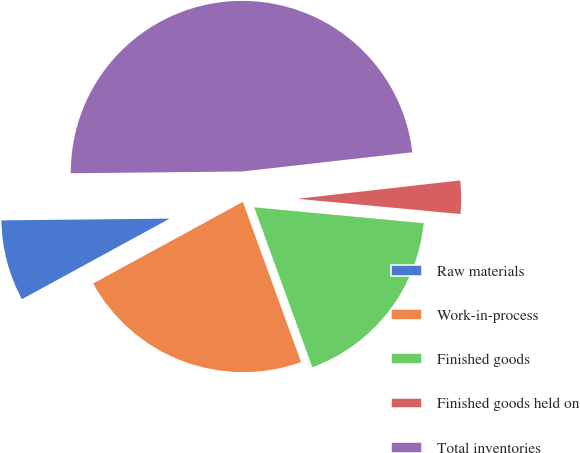<chart> <loc_0><loc_0><loc_500><loc_500><pie_chart><fcel>Raw materials<fcel>Work-in-process<fcel>Finished goods<fcel>Finished goods held on<fcel>Total inventories<nl><fcel>7.78%<fcel>22.6%<fcel>17.97%<fcel>3.27%<fcel>48.38%<nl></chart> 